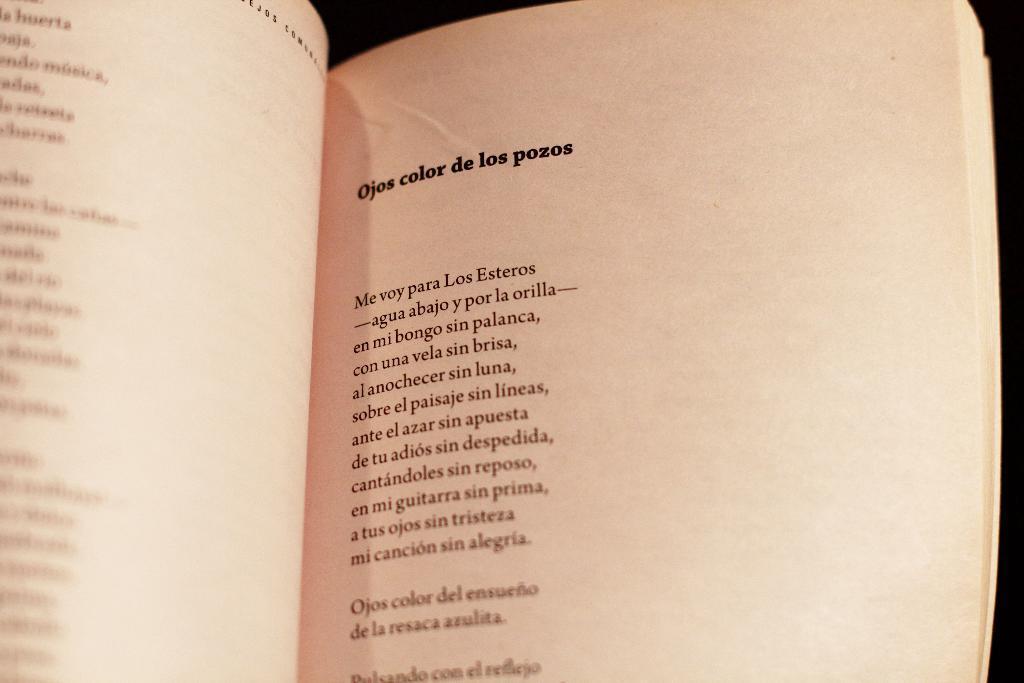Could you give a brief overview of what you see in this image? In the picture I can see an open book. On these papers I can see something written on them. 